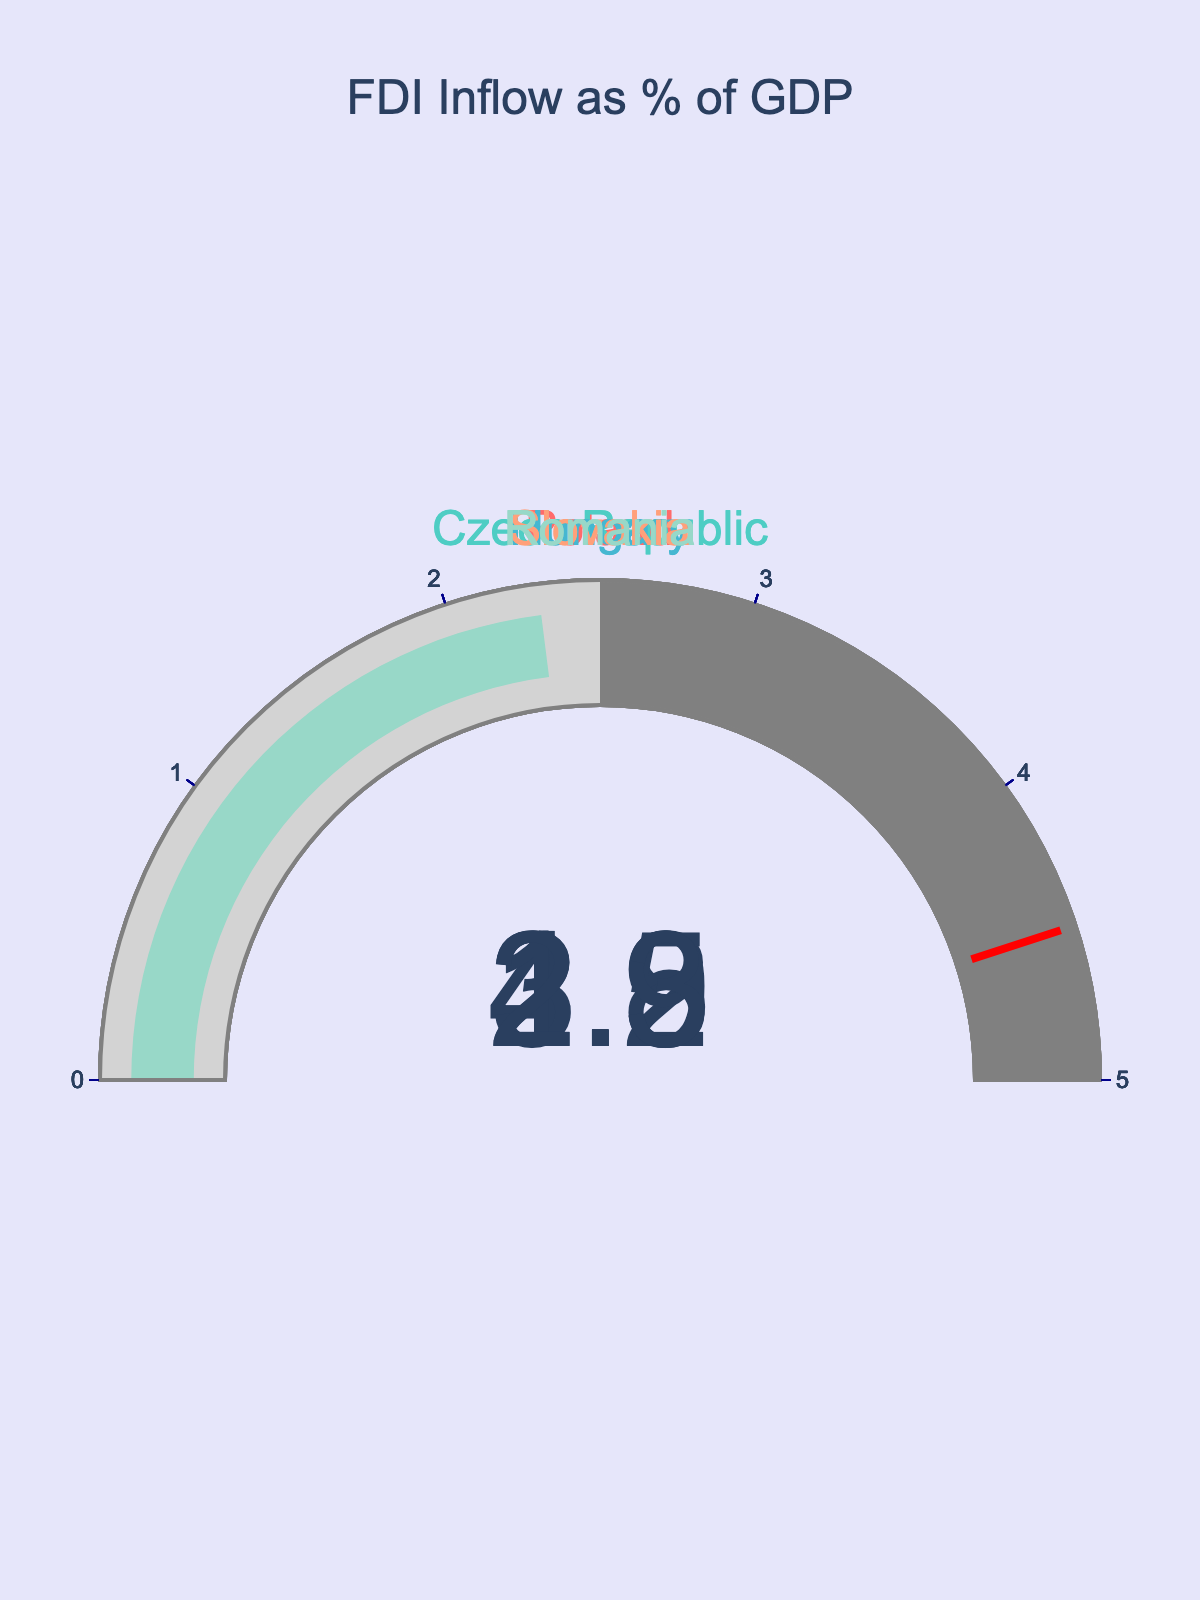What is the FDI inflow percentage of Poland? The gauge chart shows that Poland's foreign direct investment (FDI) inflow as a percentage of GDP is displayed at 2.8.
Answer: 2.8 Which country has the highest FDI inflow as a percentage of GDP? The gauge charts indicate the following FDI percentages for each country: Poland (2.8), Czech Republic (4.2), Hungary (3.5), Slovakia (1.9), and Romania (2.3). The highest percentage is 4.2, which belongs to Czech Republic.
Answer: Czech Republic What is the difference in FDI inflow percentage between Hungary and Slovakia? Hungary's FDI inflow percentage is 3.5, while Slovakia's is 1.9. The difference is calculated as 3.5 - 1.9.
Answer: 1.6 Which countries have an FDI inflow percentage below 3% of GDP? The countries with FDI percentages below 3% are Poland (2.8), Slovakia (1.9), and Romania (2.3).
Answer: Poland, Slovakia, Romania What is the average FDI inflow percentage for all the countries shown? Sum the FDI inflow percentages for Poland (2.8), Czech Republic (4.2), Hungary (3.5), Slovakia (1.9), and Romania (2.3), which totals 14.7. Then, divide by the number of countries, 5. (2.8 + 4.2 + 3.5 + 1.9 + 2.3) / 5 = 2.94
Answer: 2.94 Does Slovakia have the lowest FDI inflow percentage? Review the gauge charts: Slovakia's FDI inflow is 1.9, which is lower than all the other countries listed (2.8, 4.2, 3.5, 2.3).
Answer: Yes By how much does Poland's FDI inflow percentage exceed Romania's? Poland's FDI inflow is 2.8, and Romania's is 2.3. The difference is 2.8 - 2.3.
Answer: 0.5 Is Hungary's FDI inflow percentage higher than the average for all countries? The average FDI inflow for all countries is 2.94. Hungary's FDI inflow is 3.5, which is higher than 2.94.
Answer: Yes How many countries have an FDI inflow percentage equal to or greater than 3%? The countries meeting this criterion are Czech Republic (4.2) and Hungary (3.5).
Answer: 2 